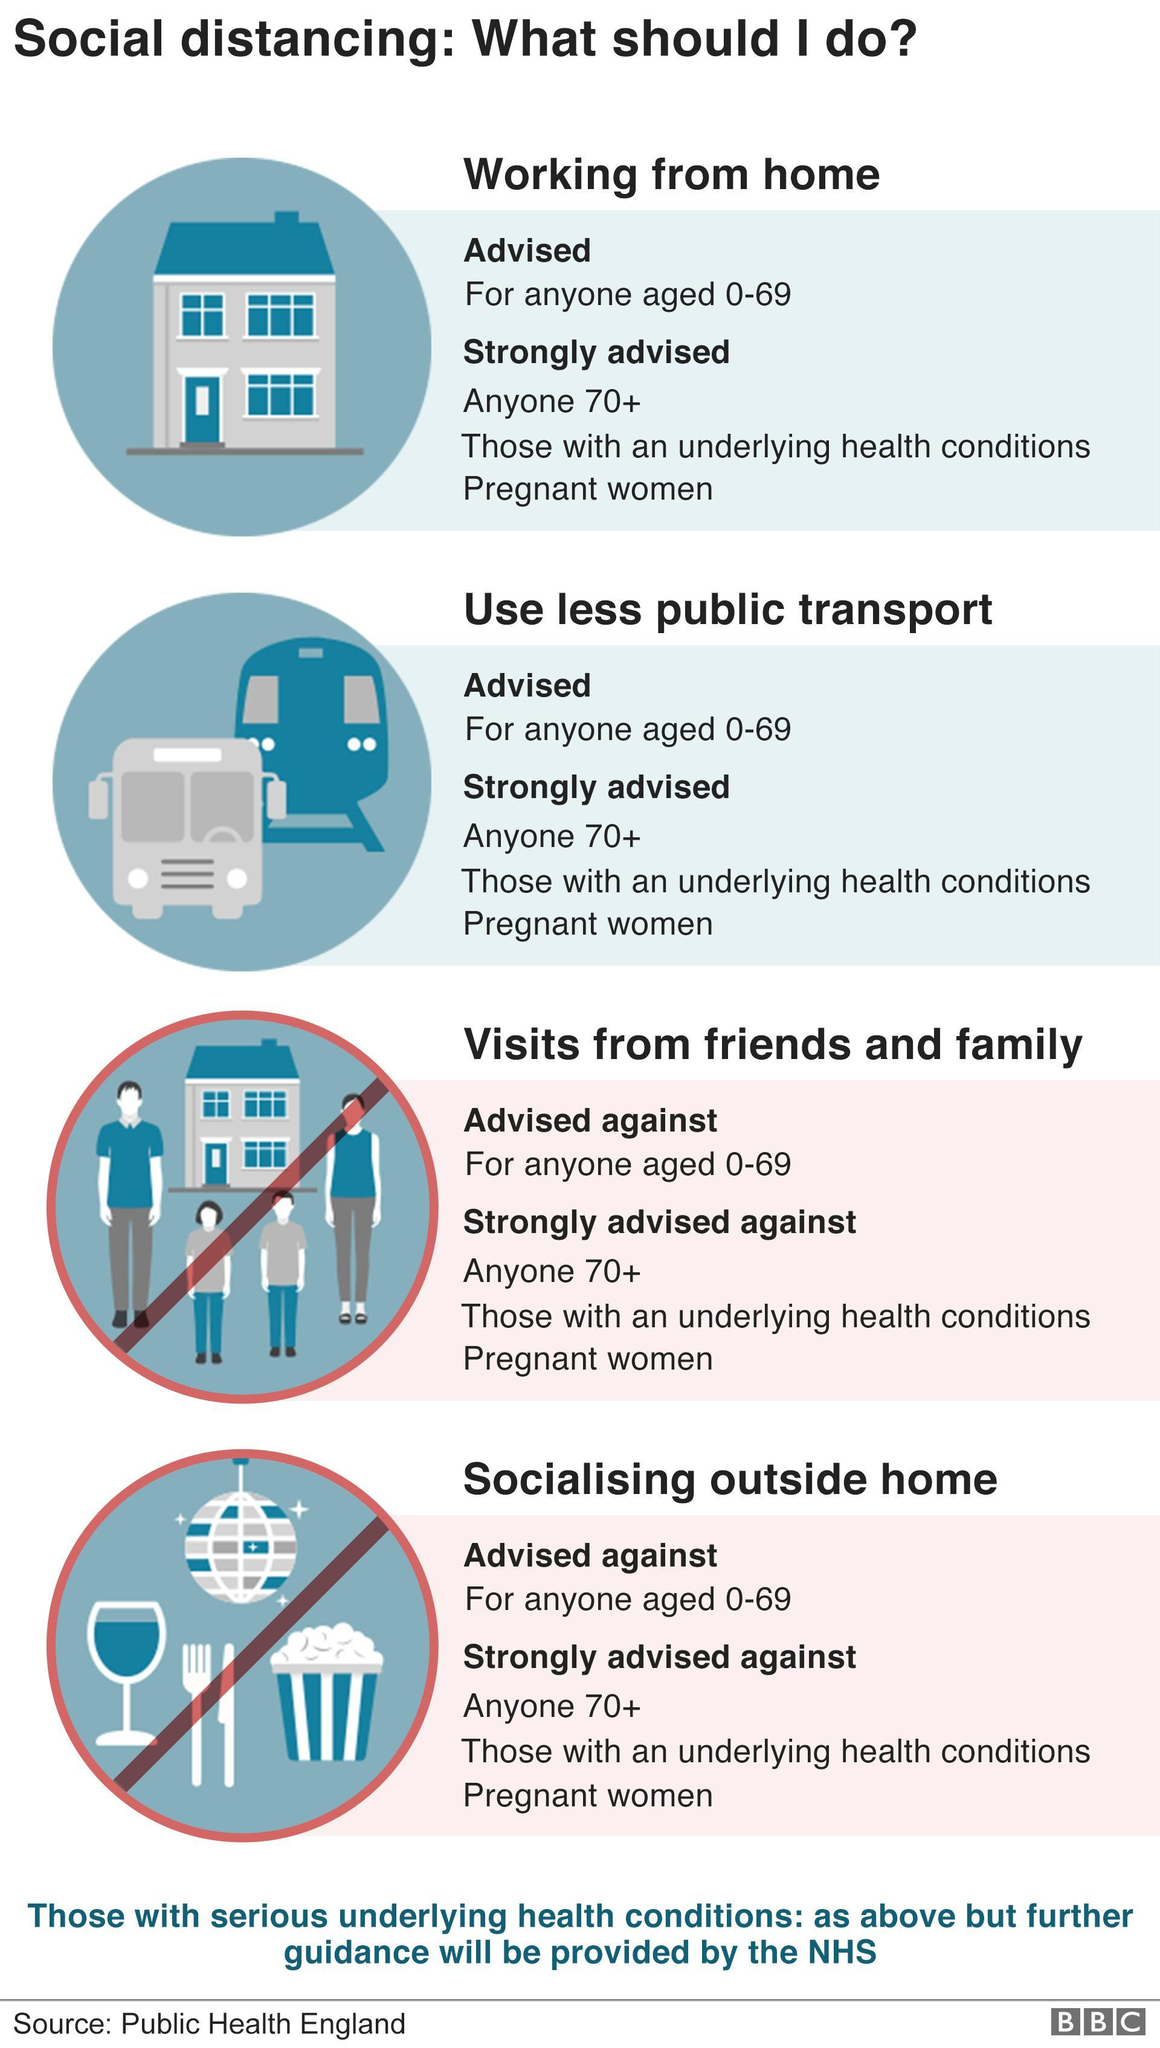How many of the advices given, are things you should do?
Answer the question with a short phrase. 2 How many of the advices given, are things you should not do? 2 What are the two things that all are advised against doing? Visits from friends and family, socialising outside home What are the two things that all are advised to do? Working from home, use less public transport What does the first image show - family, transport or home? Home What should a 75 year old person avoid doing? Visits from friends and family, socialising outside home How many advices are given here altogether? 4 What advice relating to public transportation is given to pregnant women? Use less Public transport Who are strongly advised to work from home? Anyone 70+, those with an underlying health conditions, pregnant women 